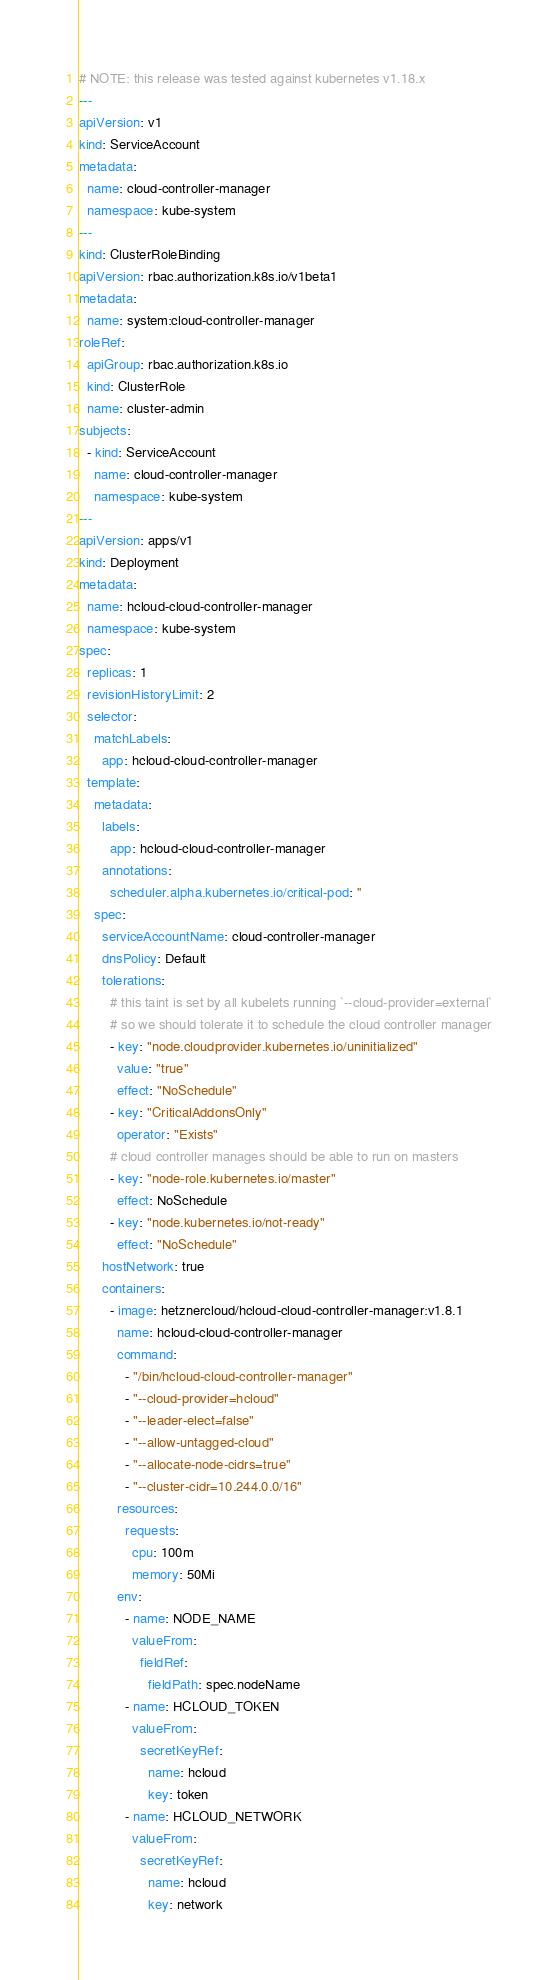Convert code to text. <code><loc_0><loc_0><loc_500><loc_500><_YAML_># NOTE: this release was tested against kubernetes v1.18.x
---
apiVersion: v1
kind: ServiceAccount
metadata:
  name: cloud-controller-manager
  namespace: kube-system
---
kind: ClusterRoleBinding
apiVersion: rbac.authorization.k8s.io/v1beta1
metadata:
  name: system:cloud-controller-manager
roleRef:
  apiGroup: rbac.authorization.k8s.io
  kind: ClusterRole
  name: cluster-admin
subjects:
  - kind: ServiceAccount
    name: cloud-controller-manager
    namespace: kube-system
---
apiVersion: apps/v1
kind: Deployment
metadata:
  name: hcloud-cloud-controller-manager
  namespace: kube-system
spec:
  replicas: 1
  revisionHistoryLimit: 2
  selector:
    matchLabels:
      app: hcloud-cloud-controller-manager
  template:
    metadata:
      labels:
        app: hcloud-cloud-controller-manager
      annotations:
        scheduler.alpha.kubernetes.io/critical-pod: ''
    spec:
      serviceAccountName: cloud-controller-manager
      dnsPolicy: Default
      tolerations:
        # this taint is set by all kubelets running `--cloud-provider=external`
        # so we should tolerate it to schedule the cloud controller manager
        - key: "node.cloudprovider.kubernetes.io/uninitialized"
          value: "true"
          effect: "NoSchedule"
        - key: "CriticalAddonsOnly"
          operator: "Exists"
        # cloud controller manages should be able to run on masters
        - key: "node-role.kubernetes.io/master"
          effect: NoSchedule
        - key: "node.kubernetes.io/not-ready"
          effect: "NoSchedule"
      hostNetwork: true
      containers:
        - image: hetznercloud/hcloud-cloud-controller-manager:v1.8.1
          name: hcloud-cloud-controller-manager
          command:
            - "/bin/hcloud-cloud-controller-manager"
            - "--cloud-provider=hcloud"
            - "--leader-elect=false"
            - "--allow-untagged-cloud"
            - "--allocate-node-cidrs=true"
            - "--cluster-cidr=10.244.0.0/16"
          resources:
            requests:
              cpu: 100m
              memory: 50Mi
          env:
            - name: NODE_NAME
              valueFrom:
                fieldRef:
                  fieldPath: spec.nodeName
            - name: HCLOUD_TOKEN
              valueFrom:
                secretKeyRef:
                  name: hcloud
                  key: token
            - name: HCLOUD_NETWORK
              valueFrom:
                secretKeyRef:
                  name: hcloud
                  key: network
</code> 